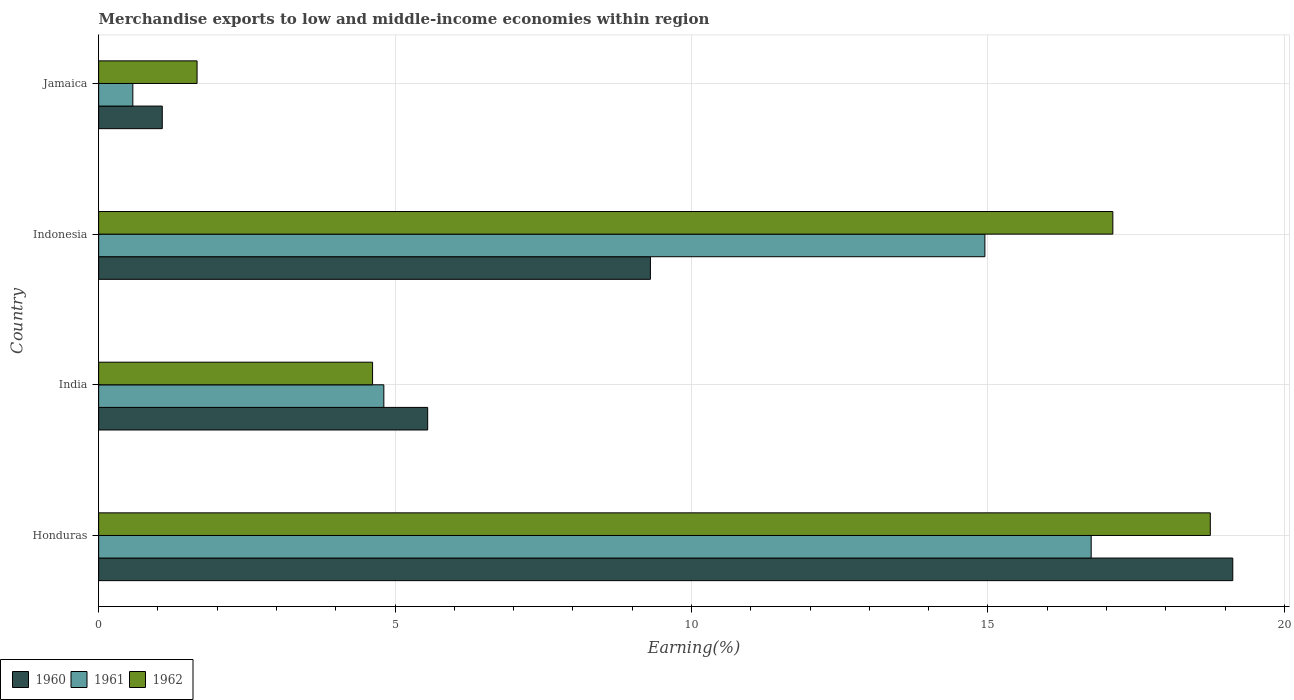How many different coloured bars are there?
Your answer should be compact. 3. Are the number of bars on each tick of the Y-axis equal?
Keep it short and to the point. Yes. How many bars are there on the 2nd tick from the top?
Provide a succinct answer. 3. How many bars are there on the 1st tick from the bottom?
Provide a succinct answer. 3. What is the percentage of amount earned from merchandise exports in 1962 in Jamaica?
Give a very brief answer. 1.66. Across all countries, what is the maximum percentage of amount earned from merchandise exports in 1960?
Your answer should be compact. 19.13. Across all countries, what is the minimum percentage of amount earned from merchandise exports in 1962?
Ensure brevity in your answer.  1.66. In which country was the percentage of amount earned from merchandise exports in 1962 maximum?
Ensure brevity in your answer.  Honduras. In which country was the percentage of amount earned from merchandise exports in 1960 minimum?
Offer a very short reply. Jamaica. What is the total percentage of amount earned from merchandise exports in 1962 in the graph?
Provide a short and direct response. 42.14. What is the difference between the percentage of amount earned from merchandise exports in 1962 in Honduras and that in Indonesia?
Ensure brevity in your answer.  1.64. What is the difference between the percentage of amount earned from merchandise exports in 1962 in India and the percentage of amount earned from merchandise exports in 1960 in Jamaica?
Offer a terse response. 3.55. What is the average percentage of amount earned from merchandise exports in 1961 per country?
Provide a succinct answer. 9.27. What is the difference between the percentage of amount earned from merchandise exports in 1961 and percentage of amount earned from merchandise exports in 1960 in Indonesia?
Keep it short and to the point. 5.64. What is the ratio of the percentage of amount earned from merchandise exports in 1960 in Honduras to that in Jamaica?
Offer a very short reply. 17.82. Is the percentage of amount earned from merchandise exports in 1962 in Honduras less than that in India?
Provide a short and direct response. No. What is the difference between the highest and the second highest percentage of amount earned from merchandise exports in 1962?
Your answer should be very brief. 1.64. What is the difference between the highest and the lowest percentage of amount earned from merchandise exports in 1962?
Your answer should be very brief. 17.09. In how many countries, is the percentage of amount earned from merchandise exports in 1962 greater than the average percentage of amount earned from merchandise exports in 1962 taken over all countries?
Your answer should be very brief. 2. Is the sum of the percentage of amount earned from merchandise exports in 1961 in Indonesia and Jamaica greater than the maximum percentage of amount earned from merchandise exports in 1960 across all countries?
Make the answer very short. No. What does the 2nd bar from the top in Jamaica represents?
Provide a succinct answer. 1961. Are all the bars in the graph horizontal?
Make the answer very short. Yes. Does the graph contain grids?
Ensure brevity in your answer.  Yes. How many legend labels are there?
Ensure brevity in your answer.  3. What is the title of the graph?
Provide a short and direct response. Merchandise exports to low and middle-income economies within region. Does "2013" appear as one of the legend labels in the graph?
Your response must be concise. No. What is the label or title of the X-axis?
Offer a terse response. Earning(%). What is the label or title of the Y-axis?
Ensure brevity in your answer.  Country. What is the Earning(%) in 1960 in Honduras?
Provide a succinct answer. 19.13. What is the Earning(%) in 1961 in Honduras?
Provide a succinct answer. 16.74. What is the Earning(%) in 1962 in Honduras?
Your answer should be compact. 18.75. What is the Earning(%) in 1960 in India?
Ensure brevity in your answer.  5.55. What is the Earning(%) in 1961 in India?
Provide a short and direct response. 4.81. What is the Earning(%) in 1962 in India?
Your response must be concise. 4.62. What is the Earning(%) of 1960 in Indonesia?
Provide a short and direct response. 9.31. What is the Earning(%) of 1961 in Indonesia?
Provide a short and direct response. 14.95. What is the Earning(%) of 1962 in Indonesia?
Your answer should be compact. 17.11. What is the Earning(%) of 1960 in Jamaica?
Make the answer very short. 1.07. What is the Earning(%) of 1961 in Jamaica?
Give a very brief answer. 0.58. What is the Earning(%) of 1962 in Jamaica?
Your answer should be very brief. 1.66. Across all countries, what is the maximum Earning(%) in 1960?
Keep it short and to the point. 19.13. Across all countries, what is the maximum Earning(%) in 1961?
Offer a very short reply. 16.74. Across all countries, what is the maximum Earning(%) in 1962?
Provide a succinct answer. 18.75. Across all countries, what is the minimum Earning(%) of 1960?
Your answer should be compact. 1.07. Across all countries, what is the minimum Earning(%) in 1961?
Keep it short and to the point. 0.58. Across all countries, what is the minimum Earning(%) in 1962?
Your response must be concise. 1.66. What is the total Earning(%) of 1960 in the graph?
Keep it short and to the point. 35.06. What is the total Earning(%) in 1961 in the graph?
Offer a very short reply. 37.08. What is the total Earning(%) in 1962 in the graph?
Ensure brevity in your answer.  42.14. What is the difference between the Earning(%) of 1960 in Honduras and that in India?
Provide a succinct answer. 13.58. What is the difference between the Earning(%) of 1961 in Honduras and that in India?
Offer a terse response. 11.93. What is the difference between the Earning(%) of 1962 in Honduras and that in India?
Offer a terse response. 14.13. What is the difference between the Earning(%) of 1960 in Honduras and that in Indonesia?
Keep it short and to the point. 9.82. What is the difference between the Earning(%) of 1961 in Honduras and that in Indonesia?
Give a very brief answer. 1.79. What is the difference between the Earning(%) of 1962 in Honduras and that in Indonesia?
Provide a short and direct response. 1.64. What is the difference between the Earning(%) in 1960 in Honduras and that in Jamaica?
Provide a short and direct response. 18.06. What is the difference between the Earning(%) in 1961 in Honduras and that in Jamaica?
Your answer should be compact. 16.16. What is the difference between the Earning(%) of 1962 in Honduras and that in Jamaica?
Provide a succinct answer. 17.09. What is the difference between the Earning(%) of 1960 in India and that in Indonesia?
Provide a short and direct response. -3.76. What is the difference between the Earning(%) of 1961 in India and that in Indonesia?
Make the answer very short. -10.14. What is the difference between the Earning(%) of 1962 in India and that in Indonesia?
Provide a succinct answer. -12.49. What is the difference between the Earning(%) of 1960 in India and that in Jamaica?
Keep it short and to the point. 4.48. What is the difference between the Earning(%) in 1961 in India and that in Jamaica?
Provide a succinct answer. 4.23. What is the difference between the Earning(%) of 1962 in India and that in Jamaica?
Offer a very short reply. 2.96. What is the difference between the Earning(%) of 1960 in Indonesia and that in Jamaica?
Your response must be concise. 8.23. What is the difference between the Earning(%) of 1961 in Indonesia and that in Jamaica?
Your answer should be compact. 14.37. What is the difference between the Earning(%) of 1962 in Indonesia and that in Jamaica?
Make the answer very short. 15.45. What is the difference between the Earning(%) in 1960 in Honduras and the Earning(%) in 1961 in India?
Your answer should be compact. 14.32. What is the difference between the Earning(%) of 1960 in Honduras and the Earning(%) of 1962 in India?
Offer a terse response. 14.51. What is the difference between the Earning(%) in 1961 in Honduras and the Earning(%) in 1962 in India?
Give a very brief answer. 12.12. What is the difference between the Earning(%) in 1960 in Honduras and the Earning(%) in 1961 in Indonesia?
Your response must be concise. 4.18. What is the difference between the Earning(%) of 1960 in Honduras and the Earning(%) of 1962 in Indonesia?
Offer a very short reply. 2.02. What is the difference between the Earning(%) in 1961 in Honduras and the Earning(%) in 1962 in Indonesia?
Provide a short and direct response. -0.37. What is the difference between the Earning(%) of 1960 in Honduras and the Earning(%) of 1961 in Jamaica?
Give a very brief answer. 18.55. What is the difference between the Earning(%) of 1960 in Honduras and the Earning(%) of 1962 in Jamaica?
Keep it short and to the point. 17.47. What is the difference between the Earning(%) in 1961 in Honduras and the Earning(%) in 1962 in Jamaica?
Make the answer very short. 15.08. What is the difference between the Earning(%) of 1960 in India and the Earning(%) of 1961 in Indonesia?
Your response must be concise. -9.4. What is the difference between the Earning(%) in 1960 in India and the Earning(%) in 1962 in Indonesia?
Provide a short and direct response. -11.56. What is the difference between the Earning(%) of 1961 in India and the Earning(%) of 1962 in Indonesia?
Keep it short and to the point. -12.3. What is the difference between the Earning(%) in 1960 in India and the Earning(%) in 1961 in Jamaica?
Give a very brief answer. 4.97. What is the difference between the Earning(%) of 1960 in India and the Earning(%) of 1962 in Jamaica?
Make the answer very short. 3.89. What is the difference between the Earning(%) of 1961 in India and the Earning(%) of 1962 in Jamaica?
Keep it short and to the point. 3.15. What is the difference between the Earning(%) of 1960 in Indonesia and the Earning(%) of 1961 in Jamaica?
Your response must be concise. 8.73. What is the difference between the Earning(%) in 1960 in Indonesia and the Earning(%) in 1962 in Jamaica?
Your answer should be very brief. 7.65. What is the difference between the Earning(%) of 1961 in Indonesia and the Earning(%) of 1962 in Jamaica?
Offer a terse response. 13.29. What is the average Earning(%) of 1960 per country?
Give a very brief answer. 8.76. What is the average Earning(%) of 1961 per country?
Keep it short and to the point. 9.27. What is the average Earning(%) in 1962 per country?
Provide a succinct answer. 10.53. What is the difference between the Earning(%) of 1960 and Earning(%) of 1961 in Honduras?
Provide a succinct answer. 2.39. What is the difference between the Earning(%) of 1960 and Earning(%) of 1962 in Honduras?
Your answer should be compact. 0.38. What is the difference between the Earning(%) in 1961 and Earning(%) in 1962 in Honduras?
Your answer should be compact. -2.01. What is the difference between the Earning(%) in 1960 and Earning(%) in 1961 in India?
Your answer should be compact. 0.74. What is the difference between the Earning(%) in 1960 and Earning(%) in 1962 in India?
Ensure brevity in your answer.  0.93. What is the difference between the Earning(%) in 1961 and Earning(%) in 1962 in India?
Provide a succinct answer. 0.19. What is the difference between the Earning(%) of 1960 and Earning(%) of 1961 in Indonesia?
Provide a short and direct response. -5.64. What is the difference between the Earning(%) in 1960 and Earning(%) in 1962 in Indonesia?
Your response must be concise. -7.8. What is the difference between the Earning(%) in 1961 and Earning(%) in 1962 in Indonesia?
Make the answer very short. -2.16. What is the difference between the Earning(%) in 1960 and Earning(%) in 1961 in Jamaica?
Your answer should be compact. 0.5. What is the difference between the Earning(%) in 1960 and Earning(%) in 1962 in Jamaica?
Your answer should be compact. -0.59. What is the difference between the Earning(%) in 1961 and Earning(%) in 1962 in Jamaica?
Your answer should be very brief. -1.08. What is the ratio of the Earning(%) of 1960 in Honduras to that in India?
Your response must be concise. 3.45. What is the ratio of the Earning(%) in 1961 in Honduras to that in India?
Offer a very short reply. 3.48. What is the ratio of the Earning(%) of 1962 in Honduras to that in India?
Offer a terse response. 4.06. What is the ratio of the Earning(%) in 1960 in Honduras to that in Indonesia?
Keep it short and to the point. 2.06. What is the ratio of the Earning(%) of 1961 in Honduras to that in Indonesia?
Give a very brief answer. 1.12. What is the ratio of the Earning(%) of 1962 in Honduras to that in Indonesia?
Your answer should be compact. 1.1. What is the ratio of the Earning(%) of 1960 in Honduras to that in Jamaica?
Your answer should be very brief. 17.82. What is the ratio of the Earning(%) in 1961 in Honduras to that in Jamaica?
Provide a short and direct response. 29.01. What is the ratio of the Earning(%) in 1962 in Honduras to that in Jamaica?
Give a very brief answer. 11.29. What is the ratio of the Earning(%) in 1960 in India to that in Indonesia?
Ensure brevity in your answer.  0.6. What is the ratio of the Earning(%) in 1961 in India to that in Indonesia?
Provide a succinct answer. 0.32. What is the ratio of the Earning(%) of 1962 in India to that in Indonesia?
Keep it short and to the point. 0.27. What is the ratio of the Earning(%) in 1960 in India to that in Jamaica?
Offer a terse response. 5.17. What is the ratio of the Earning(%) in 1961 in India to that in Jamaica?
Ensure brevity in your answer.  8.34. What is the ratio of the Earning(%) in 1962 in India to that in Jamaica?
Provide a short and direct response. 2.78. What is the ratio of the Earning(%) of 1960 in Indonesia to that in Jamaica?
Your answer should be compact. 8.67. What is the ratio of the Earning(%) of 1961 in Indonesia to that in Jamaica?
Ensure brevity in your answer.  25.91. What is the ratio of the Earning(%) of 1962 in Indonesia to that in Jamaica?
Make the answer very short. 10.3. What is the difference between the highest and the second highest Earning(%) of 1960?
Offer a very short reply. 9.82. What is the difference between the highest and the second highest Earning(%) in 1961?
Keep it short and to the point. 1.79. What is the difference between the highest and the second highest Earning(%) of 1962?
Offer a very short reply. 1.64. What is the difference between the highest and the lowest Earning(%) in 1960?
Keep it short and to the point. 18.06. What is the difference between the highest and the lowest Earning(%) in 1961?
Make the answer very short. 16.16. What is the difference between the highest and the lowest Earning(%) of 1962?
Your answer should be very brief. 17.09. 